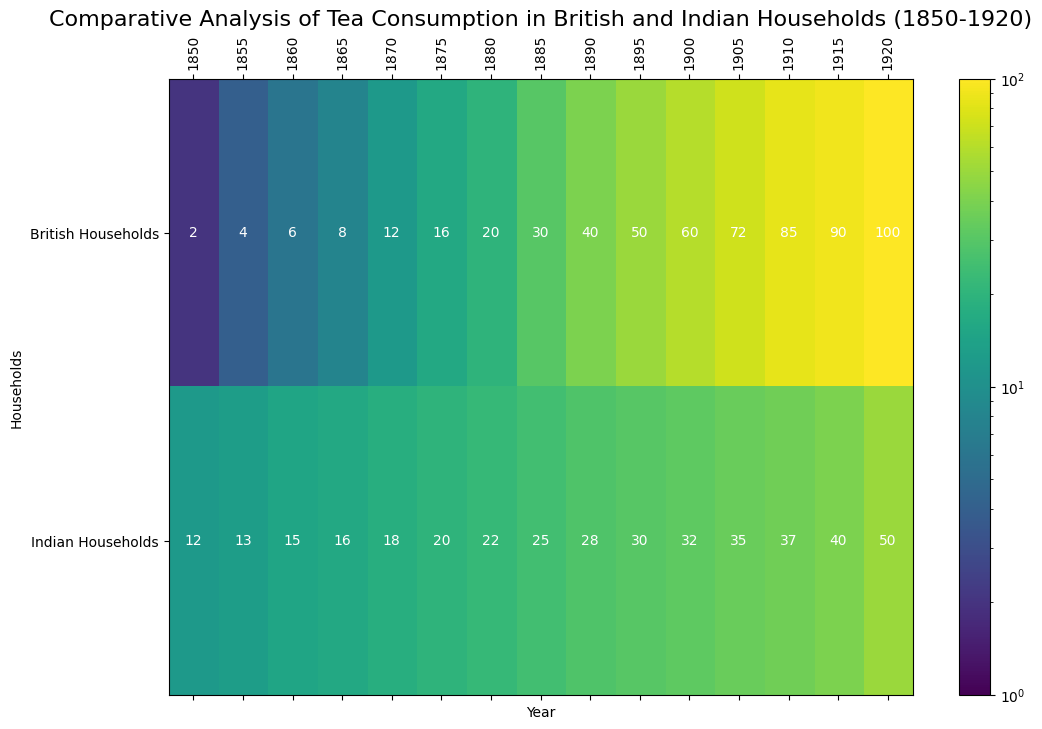Which year shows the highest tea consumption in British households? The highest consumption value for British households is 100, which is seen in the year 1920 as indicated by the column labeled 1920 and the British Households row.
Answer: 1920 How does the tea consumption in Indian households in 1905 compare to British households in the same year? Comparing the values in the 1905 column, Indian households have a tea consumption of 35, while British households have a consumption of 72. British households consumed more tea.
Answer: British households consume more What's the difference in tea consumption between British and Indian households in 1860? In 1860, the tea consumption for British households is 6, and for Indian households, it is 15. The difference can be calculated as 15 - 6 = 9.
Answer: 9 In which decade did British households see the most significant increase in tea consumption? By visual inspection of the progression, the largest jump for British households is from 1910 to 1915, where the value goes from 85 to 90. Thus, 1910-1915 shows the most significant increase.
Answer: 1910-1915 On average, was the tea consumption higher in British or Indian households during the 1870s? For the 1870s, we consider 1870 and 1875. British households’ values are 12 and 16, which average to (12+16)/2 = 14. Indian households’ values are 18 and 20, averaging (18+20)/2 = 19. Indian households have a higher average.
Answer: Indian households By looking at the color intensity, which household's tea consumption is closer to the maximum value across the entire period? The darker color in the heatmap, particularly in 1920 for British households, indicates a consumption value of 100, which is the maximum. Thus, British households’ consumption is closer to the maximum
Answer: British households Is there any year where the tea consumption is the same for both British and Indian households? By checking each column pair by pair, there isn't a year where British and Indian households have equal tea consumption values.
Answer: No Considering the trend over the years 1850-1920, how would you describe the change in tea consumption for Indian households? The trend shows a steady increase in tea consumption for Indian households from 12 in 1850 to 50 in 1920. This is a consistent upward trajectory.
Answer: Steady increase 